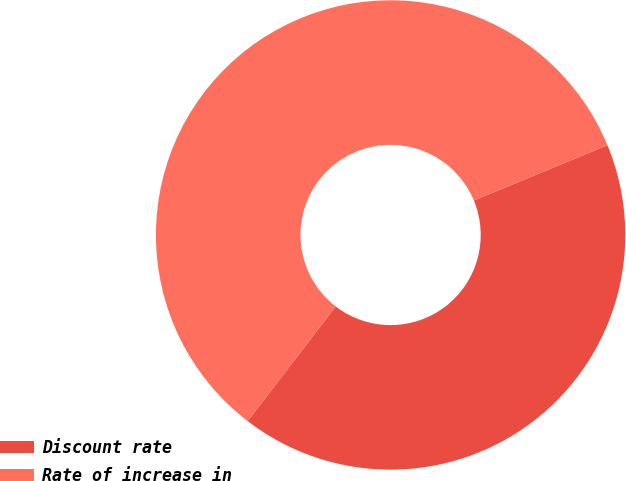Convert chart. <chart><loc_0><loc_0><loc_500><loc_500><pie_chart><fcel>Discount rate<fcel>Rate of increase in<nl><fcel>41.67%<fcel>58.33%<nl></chart> 